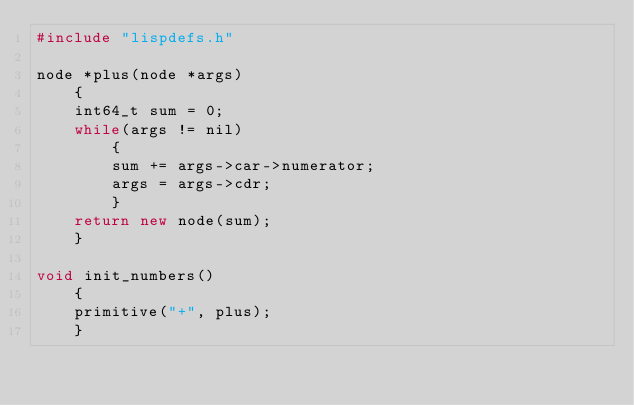Convert code to text. <code><loc_0><loc_0><loc_500><loc_500><_C++_>#include "lispdefs.h"

node *plus(node *args)
    {
    int64_t sum = 0;
    while(args != nil)
        {
        sum += args->car->numerator;
        args = args->cdr;
        }
    return new node(sum);
    }

void init_numbers()
    {
    primitive("+", plus);
    }
</code> 